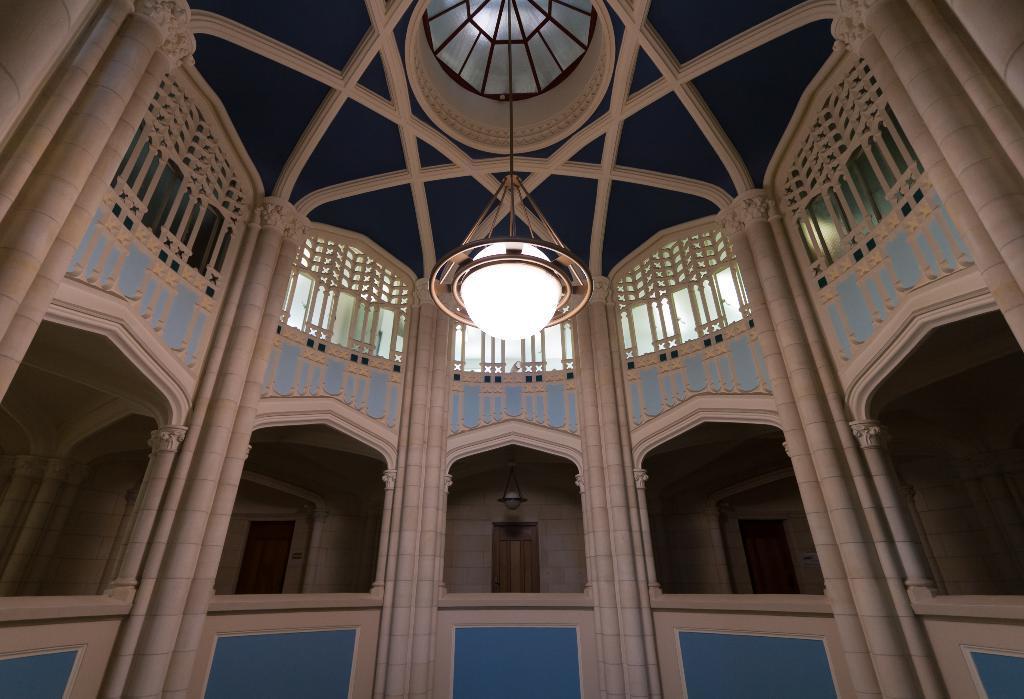In one or two sentences, can you explain what this image depicts? This picture shows an inner view of a building. We see a light hanging to the roof. 